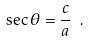<formula> <loc_0><loc_0><loc_500><loc_500>\sec \theta = { \frac { c } { a } } \ .</formula> 